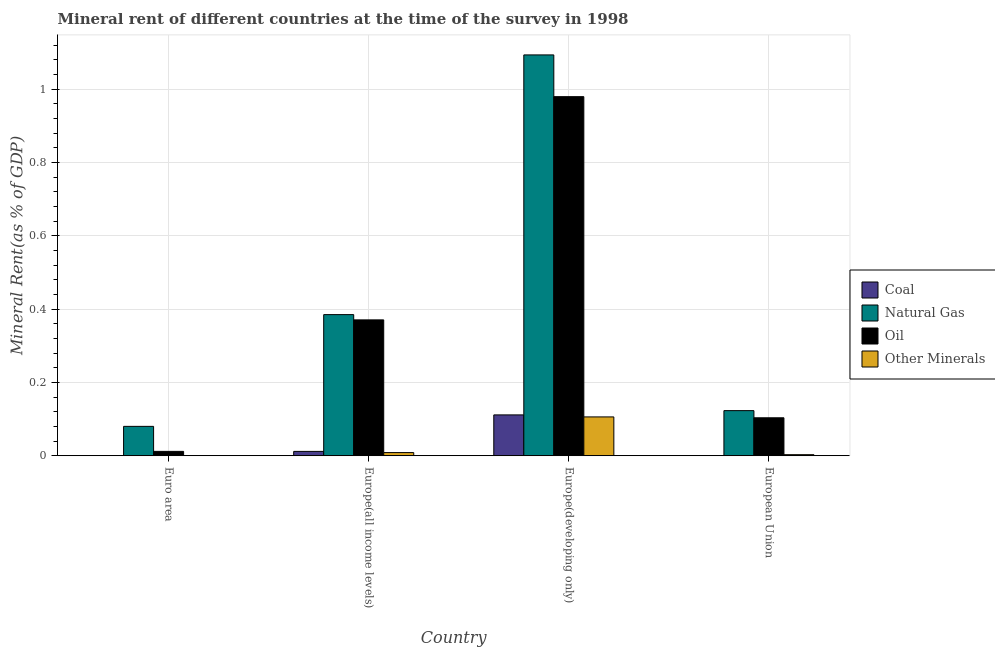How many groups of bars are there?
Make the answer very short. 4. Are the number of bars per tick equal to the number of legend labels?
Your answer should be very brief. Yes. What is the label of the 2nd group of bars from the left?
Make the answer very short. Europe(all income levels). What is the oil rent in Europe(developing only)?
Your answer should be compact. 0.98. Across all countries, what is the maximum coal rent?
Give a very brief answer. 0.11. Across all countries, what is the minimum  rent of other minerals?
Your response must be concise. 0. In which country was the natural gas rent maximum?
Keep it short and to the point. Europe(developing only). What is the total  rent of other minerals in the graph?
Your answer should be compact. 0.12. What is the difference between the oil rent in Euro area and that in European Union?
Provide a succinct answer. -0.09. What is the difference between the coal rent in European Union and the  rent of other minerals in Europe(all income levels)?
Give a very brief answer. -0.01. What is the average  rent of other minerals per country?
Make the answer very short. 0.03. What is the difference between the coal rent and  rent of other minerals in European Union?
Your answer should be compact. -0. In how many countries, is the  rent of other minerals greater than 0.44 %?
Your answer should be very brief. 0. What is the ratio of the  rent of other minerals in Europe(developing only) to that in European Union?
Offer a very short reply. 36.78. Is the  rent of other minerals in Europe(all income levels) less than that in European Union?
Offer a very short reply. No. Is the difference between the coal rent in Europe(all income levels) and Europe(developing only) greater than the difference between the oil rent in Europe(all income levels) and Europe(developing only)?
Your answer should be compact. Yes. What is the difference between the highest and the second highest  rent of other minerals?
Provide a succinct answer. 0.1. What is the difference between the highest and the lowest  rent of other minerals?
Offer a very short reply. 0.11. Is the sum of the oil rent in Europe(developing only) and European Union greater than the maximum coal rent across all countries?
Your response must be concise. Yes. What does the 1st bar from the left in Europe(all income levels) represents?
Provide a short and direct response. Coal. What does the 1st bar from the right in Euro area represents?
Your response must be concise. Other Minerals. Is it the case that in every country, the sum of the coal rent and natural gas rent is greater than the oil rent?
Offer a very short reply. Yes. How many bars are there?
Your response must be concise. 16. Are all the bars in the graph horizontal?
Your response must be concise. No. What is the difference between two consecutive major ticks on the Y-axis?
Give a very brief answer. 0.2. Are the values on the major ticks of Y-axis written in scientific E-notation?
Your response must be concise. No. Does the graph contain grids?
Make the answer very short. Yes. How many legend labels are there?
Give a very brief answer. 4. What is the title of the graph?
Ensure brevity in your answer.  Mineral rent of different countries at the time of the survey in 1998. Does "Secondary vocational education" appear as one of the legend labels in the graph?
Ensure brevity in your answer.  No. What is the label or title of the X-axis?
Offer a terse response. Country. What is the label or title of the Y-axis?
Give a very brief answer. Mineral Rent(as % of GDP). What is the Mineral Rent(as % of GDP) in Coal in Euro area?
Ensure brevity in your answer.  0. What is the Mineral Rent(as % of GDP) of Natural Gas in Euro area?
Give a very brief answer. 0.08. What is the Mineral Rent(as % of GDP) of Oil in Euro area?
Offer a very short reply. 0.01. What is the Mineral Rent(as % of GDP) in Other Minerals in Euro area?
Provide a succinct answer. 0. What is the Mineral Rent(as % of GDP) of Coal in Europe(all income levels)?
Your response must be concise. 0.01. What is the Mineral Rent(as % of GDP) in Natural Gas in Europe(all income levels)?
Offer a terse response. 0.38. What is the Mineral Rent(as % of GDP) in Oil in Europe(all income levels)?
Give a very brief answer. 0.37. What is the Mineral Rent(as % of GDP) of Other Minerals in Europe(all income levels)?
Provide a short and direct response. 0.01. What is the Mineral Rent(as % of GDP) of Coal in Europe(developing only)?
Provide a short and direct response. 0.11. What is the Mineral Rent(as % of GDP) of Natural Gas in Europe(developing only)?
Your response must be concise. 1.09. What is the Mineral Rent(as % of GDP) in Oil in Europe(developing only)?
Ensure brevity in your answer.  0.98. What is the Mineral Rent(as % of GDP) in Other Minerals in Europe(developing only)?
Keep it short and to the point. 0.11. What is the Mineral Rent(as % of GDP) in Coal in European Union?
Your answer should be very brief. 0. What is the Mineral Rent(as % of GDP) in Natural Gas in European Union?
Provide a short and direct response. 0.12. What is the Mineral Rent(as % of GDP) of Oil in European Union?
Provide a short and direct response. 0.1. What is the Mineral Rent(as % of GDP) of Other Minerals in European Union?
Your answer should be compact. 0. Across all countries, what is the maximum Mineral Rent(as % of GDP) in Coal?
Keep it short and to the point. 0.11. Across all countries, what is the maximum Mineral Rent(as % of GDP) in Natural Gas?
Your answer should be compact. 1.09. Across all countries, what is the maximum Mineral Rent(as % of GDP) in Oil?
Keep it short and to the point. 0.98. Across all countries, what is the maximum Mineral Rent(as % of GDP) in Other Minerals?
Make the answer very short. 0.11. Across all countries, what is the minimum Mineral Rent(as % of GDP) in Coal?
Provide a succinct answer. 0. Across all countries, what is the minimum Mineral Rent(as % of GDP) in Natural Gas?
Your answer should be compact. 0.08. Across all countries, what is the minimum Mineral Rent(as % of GDP) of Oil?
Offer a very short reply. 0.01. Across all countries, what is the minimum Mineral Rent(as % of GDP) of Other Minerals?
Ensure brevity in your answer.  0. What is the total Mineral Rent(as % of GDP) of Coal in the graph?
Offer a terse response. 0.12. What is the total Mineral Rent(as % of GDP) in Natural Gas in the graph?
Keep it short and to the point. 1.68. What is the total Mineral Rent(as % of GDP) of Oil in the graph?
Offer a terse response. 1.47. What is the total Mineral Rent(as % of GDP) of Other Minerals in the graph?
Keep it short and to the point. 0.12. What is the difference between the Mineral Rent(as % of GDP) of Coal in Euro area and that in Europe(all income levels)?
Keep it short and to the point. -0.01. What is the difference between the Mineral Rent(as % of GDP) of Natural Gas in Euro area and that in Europe(all income levels)?
Ensure brevity in your answer.  -0.3. What is the difference between the Mineral Rent(as % of GDP) of Oil in Euro area and that in Europe(all income levels)?
Give a very brief answer. -0.36. What is the difference between the Mineral Rent(as % of GDP) of Other Minerals in Euro area and that in Europe(all income levels)?
Provide a succinct answer. -0.01. What is the difference between the Mineral Rent(as % of GDP) of Coal in Euro area and that in Europe(developing only)?
Offer a terse response. -0.11. What is the difference between the Mineral Rent(as % of GDP) in Natural Gas in Euro area and that in Europe(developing only)?
Ensure brevity in your answer.  -1.01. What is the difference between the Mineral Rent(as % of GDP) in Oil in Euro area and that in Europe(developing only)?
Make the answer very short. -0.97. What is the difference between the Mineral Rent(as % of GDP) of Other Minerals in Euro area and that in Europe(developing only)?
Your answer should be very brief. -0.11. What is the difference between the Mineral Rent(as % of GDP) of Natural Gas in Euro area and that in European Union?
Give a very brief answer. -0.04. What is the difference between the Mineral Rent(as % of GDP) in Oil in Euro area and that in European Union?
Provide a succinct answer. -0.09. What is the difference between the Mineral Rent(as % of GDP) in Other Minerals in Euro area and that in European Union?
Offer a terse response. -0. What is the difference between the Mineral Rent(as % of GDP) of Coal in Europe(all income levels) and that in Europe(developing only)?
Provide a succinct answer. -0.1. What is the difference between the Mineral Rent(as % of GDP) of Natural Gas in Europe(all income levels) and that in Europe(developing only)?
Give a very brief answer. -0.71. What is the difference between the Mineral Rent(as % of GDP) in Oil in Europe(all income levels) and that in Europe(developing only)?
Offer a terse response. -0.61. What is the difference between the Mineral Rent(as % of GDP) in Other Minerals in Europe(all income levels) and that in Europe(developing only)?
Give a very brief answer. -0.1. What is the difference between the Mineral Rent(as % of GDP) of Coal in Europe(all income levels) and that in European Union?
Your response must be concise. 0.01. What is the difference between the Mineral Rent(as % of GDP) of Natural Gas in Europe(all income levels) and that in European Union?
Keep it short and to the point. 0.26. What is the difference between the Mineral Rent(as % of GDP) of Oil in Europe(all income levels) and that in European Union?
Your answer should be compact. 0.27. What is the difference between the Mineral Rent(as % of GDP) of Other Minerals in Europe(all income levels) and that in European Union?
Make the answer very short. 0.01. What is the difference between the Mineral Rent(as % of GDP) in Coal in Europe(developing only) and that in European Union?
Offer a terse response. 0.11. What is the difference between the Mineral Rent(as % of GDP) in Natural Gas in Europe(developing only) and that in European Union?
Your response must be concise. 0.97. What is the difference between the Mineral Rent(as % of GDP) in Oil in Europe(developing only) and that in European Union?
Provide a succinct answer. 0.88. What is the difference between the Mineral Rent(as % of GDP) of Other Minerals in Europe(developing only) and that in European Union?
Your answer should be very brief. 0.1. What is the difference between the Mineral Rent(as % of GDP) in Coal in Euro area and the Mineral Rent(as % of GDP) in Natural Gas in Europe(all income levels)?
Offer a very short reply. -0.38. What is the difference between the Mineral Rent(as % of GDP) of Coal in Euro area and the Mineral Rent(as % of GDP) of Oil in Europe(all income levels)?
Ensure brevity in your answer.  -0.37. What is the difference between the Mineral Rent(as % of GDP) of Coal in Euro area and the Mineral Rent(as % of GDP) of Other Minerals in Europe(all income levels)?
Provide a succinct answer. -0.01. What is the difference between the Mineral Rent(as % of GDP) in Natural Gas in Euro area and the Mineral Rent(as % of GDP) in Oil in Europe(all income levels)?
Provide a short and direct response. -0.29. What is the difference between the Mineral Rent(as % of GDP) in Natural Gas in Euro area and the Mineral Rent(as % of GDP) in Other Minerals in Europe(all income levels)?
Provide a succinct answer. 0.07. What is the difference between the Mineral Rent(as % of GDP) of Oil in Euro area and the Mineral Rent(as % of GDP) of Other Minerals in Europe(all income levels)?
Give a very brief answer. 0. What is the difference between the Mineral Rent(as % of GDP) in Coal in Euro area and the Mineral Rent(as % of GDP) in Natural Gas in Europe(developing only)?
Your answer should be compact. -1.09. What is the difference between the Mineral Rent(as % of GDP) of Coal in Euro area and the Mineral Rent(as % of GDP) of Oil in Europe(developing only)?
Make the answer very short. -0.98. What is the difference between the Mineral Rent(as % of GDP) of Coal in Euro area and the Mineral Rent(as % of GDP) of Other Minerals in Europe(developing only)?
Your response must be concise. -0.11. What is the difference between the Mineral Rent(as % of GDP) in Natural Gas in Euro area and the Mineral Rent(as % of GDP) in Oil in Europe(developing only)?
Offer a very short reply. -0.9. What is the difference between the Mineral Rent(as % of GDP) in Natural Gas in Euro area and the Mineral Rent(as % of GDP) in Other Minerals in Europe(developing only)?
Your answer should be very brief. -0.03. What is the difference between the Mineral Rent(as % of GDP) in Oil in Euro area and the Mineral Rent(as % of GDP) in Other Minerals in Europe(developing only)?
Offer a terse response. -0.09. What is the difference between the Mineral Rent(as % of GDP) in Coal in Euro area and the Mineral Rent(as % of GDP) in Natural Gas in European Union?
Make the answer very short. -0.12. What is the difference between the Mineral Rent(as % of GDP) in Coal in Euro area and the Mineral Rent(as % of GDP) in Oil in European Union?
Offer a very short reply. -0.1. What is the difference between the Mineral Rent(as % of GDP) in Coal in Euro area and the Mineral Rent(as % of GDP) in Other Minerals in European Union?
Your answer should be very brief. -0. What is the difference between the Mineral Rent(as % of GDP) of Natural Gas in Euro area and the Mineral Rent(as % of GDP) of Oil in European Union?
Your answer should be very brief. -0.02. What is the difference between the Mineral Rent(as % of GDP) of Natural Gas in Euro area and the Mineral Rent(as % of GDP) of Other Minerals in European Union?
Your answer should be very brief. 0.08. What is the difference between the Mineral Rent(as % of GDP) in Oil in Euro area and the Mineral Rent(as % of GDP) in Other Minerals in European Union?
Your answer should be very brief. 0.01. What is the difference between the Mineral Rent(as % of GDP) of Coal in Europe(all income levels) and the Mineral Rent(as % of GDP) of Natural Gas in Europe(developing only)?
Offer a very short reply. -1.08. What is the difference between the Mineral Rent(as % of GDP) of Coal in Europe(all income levels) and the Mineral Rent(as % of GDP) of Oil in Europe(developing only)?
Make the answer very short. -0.97. What is the difference between the Mineral Rent(as % of GDP) in Coal in Europe(all income levels) and the Mineral Rent(as % of GDP) in Other Minerals in Europe(developing only)?
Keep it short and to the point. -0.09. What is the difference between the Mineral Rent(as % of GDP) in Natural Gas in Europe(all income levels) and the Mineral Rent(as % of GDP) in Oil in Europe(developing only)?
Provide a short and direct response. -0.59. What is the difference between the Mineral Rent(as % of GDP) in Natural Gas in Europe(all income levels) and the Mineral Rent(as % of GDP) in Other Minerals in Europe(developing only)?
Your answer should be very brief. 0.28. What is the difference between the Mineral Rent(as % of GDP) of Oil in Europe(all income levels) and the Mineral Rent(as % of GDP) of Other Minerals in Europe(developing only)?
Make the answer very short. 0.26. What is the difference between the Mineral Rent(as % of GDP) in Coal in Europe(all income levels) and the Mineral Rent(as % of GDP) in Natural Gas in European Union?
Offer a very short reply. -0.11. What is the difference between the Mineral Rent(as % of GDP) of Coal in Europe(all income levels) and the Mineral Rent(as % of GDP) of Oil in European Union?
Offer a terse response. -0.09. What is the difference between the Mineral Rent(as % of GDP) of Coal in Europe(all income levels) and the Mineral Rent(as % of GDP) of Other Minerals in European Union?
Keep it short and to the point. 0.01. What is the difference between the Mineral Rent(as % of GDP) in Natural Gas in Europe(all income levels) and the Mineral Rent(as % of GDP) in Oil in European Union?
Offer a terse response. 0.28. What is the difference between the Mineral Rent(as % of GDP) in Natural Gas in Europe(all income levels) and the Mineral Rent(as % of GDP) in Other Minerals in European Union?
Keep it short and to the point. 0.38. What is the difference between the Mineral Rent(as % of GDP) in Oil in Europe(all income levels) and the Mineral Rent(as % of GDP) in Other Minerals in European Union?
Provide a succinct answer. 0.37. What is the difference between the Mineral Rent(as % of GDP) in Coal in Europe(developing only) and the Mineral Rent(as % of GDP) in Natural Gas in European Union?
Provide a succinct answer. -0.01. What is the difference between the Mineral Rent(as % of GDP) of Coal in Europe(developing only) and the Mineral Rent(as % of GDP) of Oil in European Union?
Give a very brief answer. 0.01. What is the difference between the Mineral Rent(as % of GDP) of Coal in Europe(developing only) and the Mineral Rent(as % of GDP) of Other Minerals in European Union?
Make the answer very short. 0.11. What is the difference between the Mineral Rent(as % of GDP) in Natural Gas in Europe(developing only) and the Mineral Rent(as % of GDP) in Oil in European Union?
Make the answer very short. 0.99. What is the difference between the Mineral Rent(as % of GDP) in Natural Gas in Europe(developing only) and the Mineral Rent(as % of GDP) in Other Minerals in European Union?
Your response must be concise. 1.09. What is the difference between the Mineral Rent(as % of GDP) of Oil in Europe(developing only) and the Mineral Rent(as % of GDP) of Other Minerals in European Union?
Make the answer very short. 0.98. What is the average Mineral Rent(as % of GDP) of Coal per country?
Keep it short and to the point. 0.03. What is the average Mineral Rent(as % of GDP) in Natural Gas per country?
Offer a terse response. 0.42. What is the average Mineral Rent(as % of GDP) of Oil per country?
Offer a very short reply. 0.37. What is the average Mineral Rent(as % of GDP) of Other Minerals per country?
Give a very brief answer. 0.03. What is the difference between the Mineral Rent(as % of GDP) in Coal and Mineral Rent(as % of GDP) in Natural Gas in Euro area?
Make the answer very short. -0.08. What is the difference between the Mineral Rent(as % of GDP) in Coal and Mineral Rent(as % of GDP) in Oil in Euro area?
Keep it short and to the point. -0.01. What is the difference between the Mineral Rent(as % of GDP) in Coal and Mineral Rent(as % of GDP) in Other Minerals in Euro area?
Your answer should be very brief. -0. What is the difference between the Mineral Rent(as % of GDP) in Natural Gas and Mineral Rent(as % of GDP) in Oil in Euro area?
Offer a very short reply. 0.07. What is the difference between the Mineral Rent(as % of GDP) of Natural Gas and Mineral Rent(as % of GDP) of Other Minerals in Euro area?
Keep it short and to the point. 0.08. What is the difference between the Mineral Rent(as % of GDP) of Oil and Mineral Rent(as % of GDP) of Other Minerals in Euro area?
Your answer should be compact. 0.01. What is the difference between the Mineral Rent(as % of GDP) in Coal and Mineral Rent(as % of GDP) in Natural Gas in Europe(all income levels)?
Make the answer very short. -0.37. What is the difference between the Mineral Rent(as % of GDP) of Coal and Mineral Rent(as % of GDP) of Oil in Europe(all income levels)?
Offer a terse response. -0.36. What is the difference between the Mineral Rent(as % of GDP) of Coal and Mineral Rent(as % of GDP) of Other Minerals in Europe(all income levels)?
Offer a very short reply. 0. What is the difference between the Mineral Rent(as % of GDP) in Natural Gas and Mineral Rent(as % of GDP) in Oil in Europe(all income levels)?
Provide a succinct answer. 0.01. What is the difference between the Mineral Rent(as % of GDP) in Natural Gas and Mineral Rent(as % of GDP) in Other Minerals in Europe(all income levels)?
Your answer should be very brief. 0.38. What is the difference between the Mineral Rent(as % of GDP) in Oil and Mineral Rent(as % of GDP) in Other Minerals in Europe(all income levels)?
Your answer should be very brief. 0.36. What is the difference between the Mineral Rent(as % of GDP) of Coal and Mineral Rent(as % of GDP) of Natural Gas in Europe(developing only)?
Offer a terse response. -0.98. What is the difference between the Mineral Rent(as % of GDP) of Coal and Mineral Rent(as % of GDP) of Oil in Europe(developing only)?
Offer a very short reply. -0.87. What is the difference between the Mineral Rent(as % of GDP) in Coal and Mineral Rent(as % of GDP) in Other Minerals in Europe(developing only)?
Provide a succinct answer. 0.01. What is the difference between the Mineral Rent(as % of GDP) in Natural Gas and Mineral Rent(as % of GDP) in Oil in Europe(developing only)?
Offer a very short reply. 0.11. What is the difference between the Mineral Rent(as % of GDP) of Oil and Mineral Rent(as % of GDP) of Other Minerals in Europe(developing only)?
Keep it short and to the point. 0.87. What is the difference between the Mineral Rent(as % of GDP) of Coal and Mineral Rent(as % of GDP) of Natural Gas in European Union?
Make the answer very short. -0.12. What is the difference between the Mineral Rent(as % of GDP) of Coal and Mineral Rent(as % of GDP) of Oil in European Union?
Keep it short and to the point. -0.1. What is the difference between the Mineral Rent(as % of GDP) in Coal and Mineral Rent(as % of GDP) in Other Minerals in European Union?
Provide a succinct answer. -0. What is the difference between the Mineral Rent(as % of GDP) in Natural Gas and Mineral Rent(as % of GDP) in Oil in European Union?
Your answer should be compact. 0.02. What is the difference between the Mineral Rent(as % of GDP) of Natural Gas and Mineral Rent(as % of GDP) of Other Minerals in European Union?
Your answer should be compact. 0.12. What is the difference between the Mineral Rent(as % of GDP) of Oil and Mineral Rent(as % of GDP) of Other Minerals in European Union?
Provide a short and direct response. 0.1. What is the ratio of the Mineral Rent(as % of GDP) in Coal in Euro area to that in Europe(all income levels)?
Offer a very short reply. 0.02. What is the ratio of the Mineral Rent(as % of GDP) of Natural Gas in Euro area to that in Europe(all income levels)?
Your answer should be compact. 0.21. What is the ratio of the Mineral Rent(as % of GDP) in Oil in Euro area to that in Europe(all income levels)?
Make the answer very short. 0.03. What is the ratio of the Mineral Rent(as % of GDP) of Other Minerals in Euro area to that in Europe(all income levels)?
Ensure brevity in your answer.  0.03. What is the ratio of the Mineral Rent(as % of GDP) in Coal in Euro area to that in Europe(developing only)?
Offer a terse response. 0. What is the ratio of the Mineral Rent(as % of GDP) in Natural Gas in Euro area to that in Europe(developing only)?
Your response must be concise. 0.07. What is the ratio of the Mineral Rent(as % of GDP) in Oil in Euro area to that in Europe(developing only)?
Your answer should be compact. 0.01. What is the ratio of the Mineral Rent(as % of GDP) in Other Minerals in Euro area to that in Europe(developing only)?
Keep it short and to the point. 0. What is the ratio of the Mineral Rent(as % of GDP) of Coal in Euro area to that in European Union?
Your answer should be very brief. 1.33. What is the ratio of the Mineral Rent(as % of GDP) in Natural Gas in Euro area to that in European Union?
Your response must be concise. 0.65. What is the ratio of the Mineral Rent(as % of GDP) in Oil in Euro area to that in European Union?
Offer a very short reply. 0.11. What is the ratio of the Mineral Rent(as % of GDP) in Other Minerals in Euro area to that in European Union?
Make the answer very short. 0.09. What is the ratio of the Mineral Rent(as % of GDP) of Coal in Europe(all income levels) to that in Europe(developing only)?
Provide a succinct answer. 0.11. What is the ratio of the Mineral Rent(as % of GDP) of Natural Gas in Europe(all income levels) to that in Europe(developing only)?
Provide a succinct answer. 0.35. What is the ratio of the Mineral Rent(as % of GDP) of Oil in Europe(all income levels) to that in Europe(developing only)?
Ensure brevity in your answer.  0.38. What is the ratio of the Mineral Rent(as % of GDP) in Other Minerals in Europe(all income levels) to that in Europe(developing only)?
Ensure brevity in your answer.  0.08. What is the ratio of the Mineral Rent(as % of GDP) of Coal in Europe(all income levels) to that in European Union?
Provide a short and direct response. 74.99. What is the ratio of the Mineral Rent(as % of GDP) in Natural Gas in Europe(all income levels) to that in European Union?
Your response must be concise. 3.13. What is the ratio of the Mineral Rent(as % of GDP) in Oil in Europe(all income levels) to that in European Union?
Your response must be concise. 3.58. What is the ratio of the Mineral Rent(as % of GDP) of Other Minerals in Europe(all income levels) to that in European Union?
Ensure brevity in your answer.  2.98. What is the ratio of the Mineral Rent(as % of GDP) in Coal in Europe(developing only) to that in European Union?
Provide a succinct answer. 707.82. What is the ratio of the Mineral Rent(as % of GDP) of Natural Gas in Europe(developing only) to that in European Union?
Offer a very short reply. 8.89. What is the ratio of the Mineral Rent(as % of GDP) in Oil in Europe(developing only) to that in European Union?
Offer a terse response. 9.46. What is the ratio of the Mineral Rent(as % of GDP) in Other Minerals in Europe(developing only) to that in European Union?
Your answer should be very brief. 36.78. What is the difference between the highest and the second highest Mineral Rent(as % of GDP) of Coal?
Provide a short and direct response. 0.1. What is the difference between the highest and the second highest Mineral Rent(as % of GDP) in Natural Gas?
Give a very brief answer. 0.71. What is the difference between the highest and the second highest Mineral Rent(as % of GDP) in Oil?
Make the answer very short. 0.61. What is the difference between the highest and the second highest Mineral Rent(as % of GDP) of Other Minerals?
Offer a very short reply. 0.1. What is the difference between the highest and the lowest Mineral Rent(as % of GDP) of Coal?
Your response must be concise. 0.11. What is the difference between the highest and the lowest Mineral Rent(as % of GDP) of Natural Gas?
Your response must be concise. 1.01. What is the difference between the highest and the lowest Mineral Rent(as % of GDP) in Oil?
Your response must be concise. 0.97. What is the difference between the highest and the lowest Mineral Rent(as % of GDP) in Other Minerals?
Offer a terse response. 0.11. 